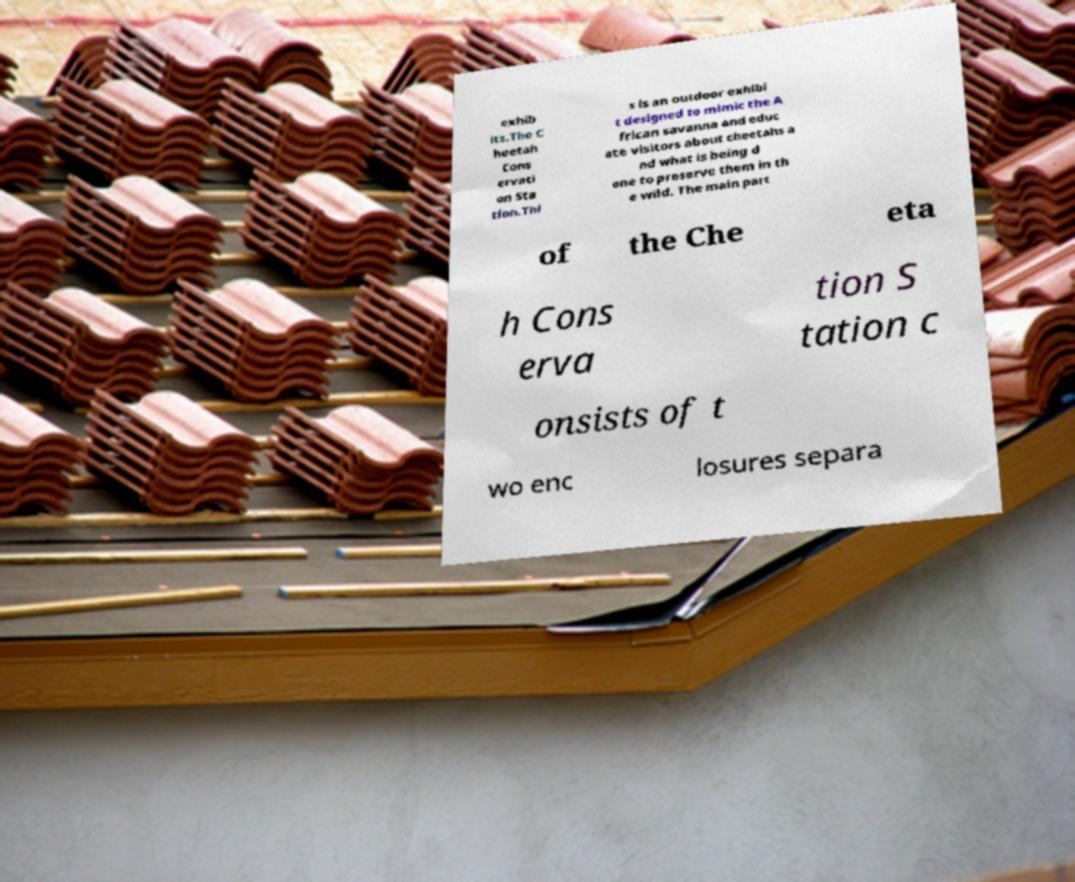What messages or text are displayed in this image? I need them in a readable, typed format. exhib its.The C heetah Cons ervati on Sta tion.Thi s is an outdoor exhibi t designed to mimic the A frican savanna and educ ate visitors about cheetahs a nd what is being d one to preserve them in th e wild. The main part of the Che eta h Cons erva tion S tation c onsists of t wo enc losures separa 